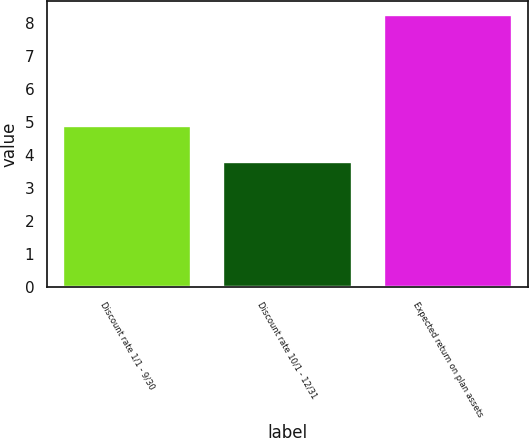Convert chart to OTSL. <chart><loc_0><loc_0><loc_500><loc_500><bar_chart><fcel>Discount rate 1/1 - 9/30<fcel>Discount rate 10/1 - 12/31<fcel>Expected return on plan assets<nl><fcel>4.89<fcel>3.8<fcel>8.25<nl></chart> 